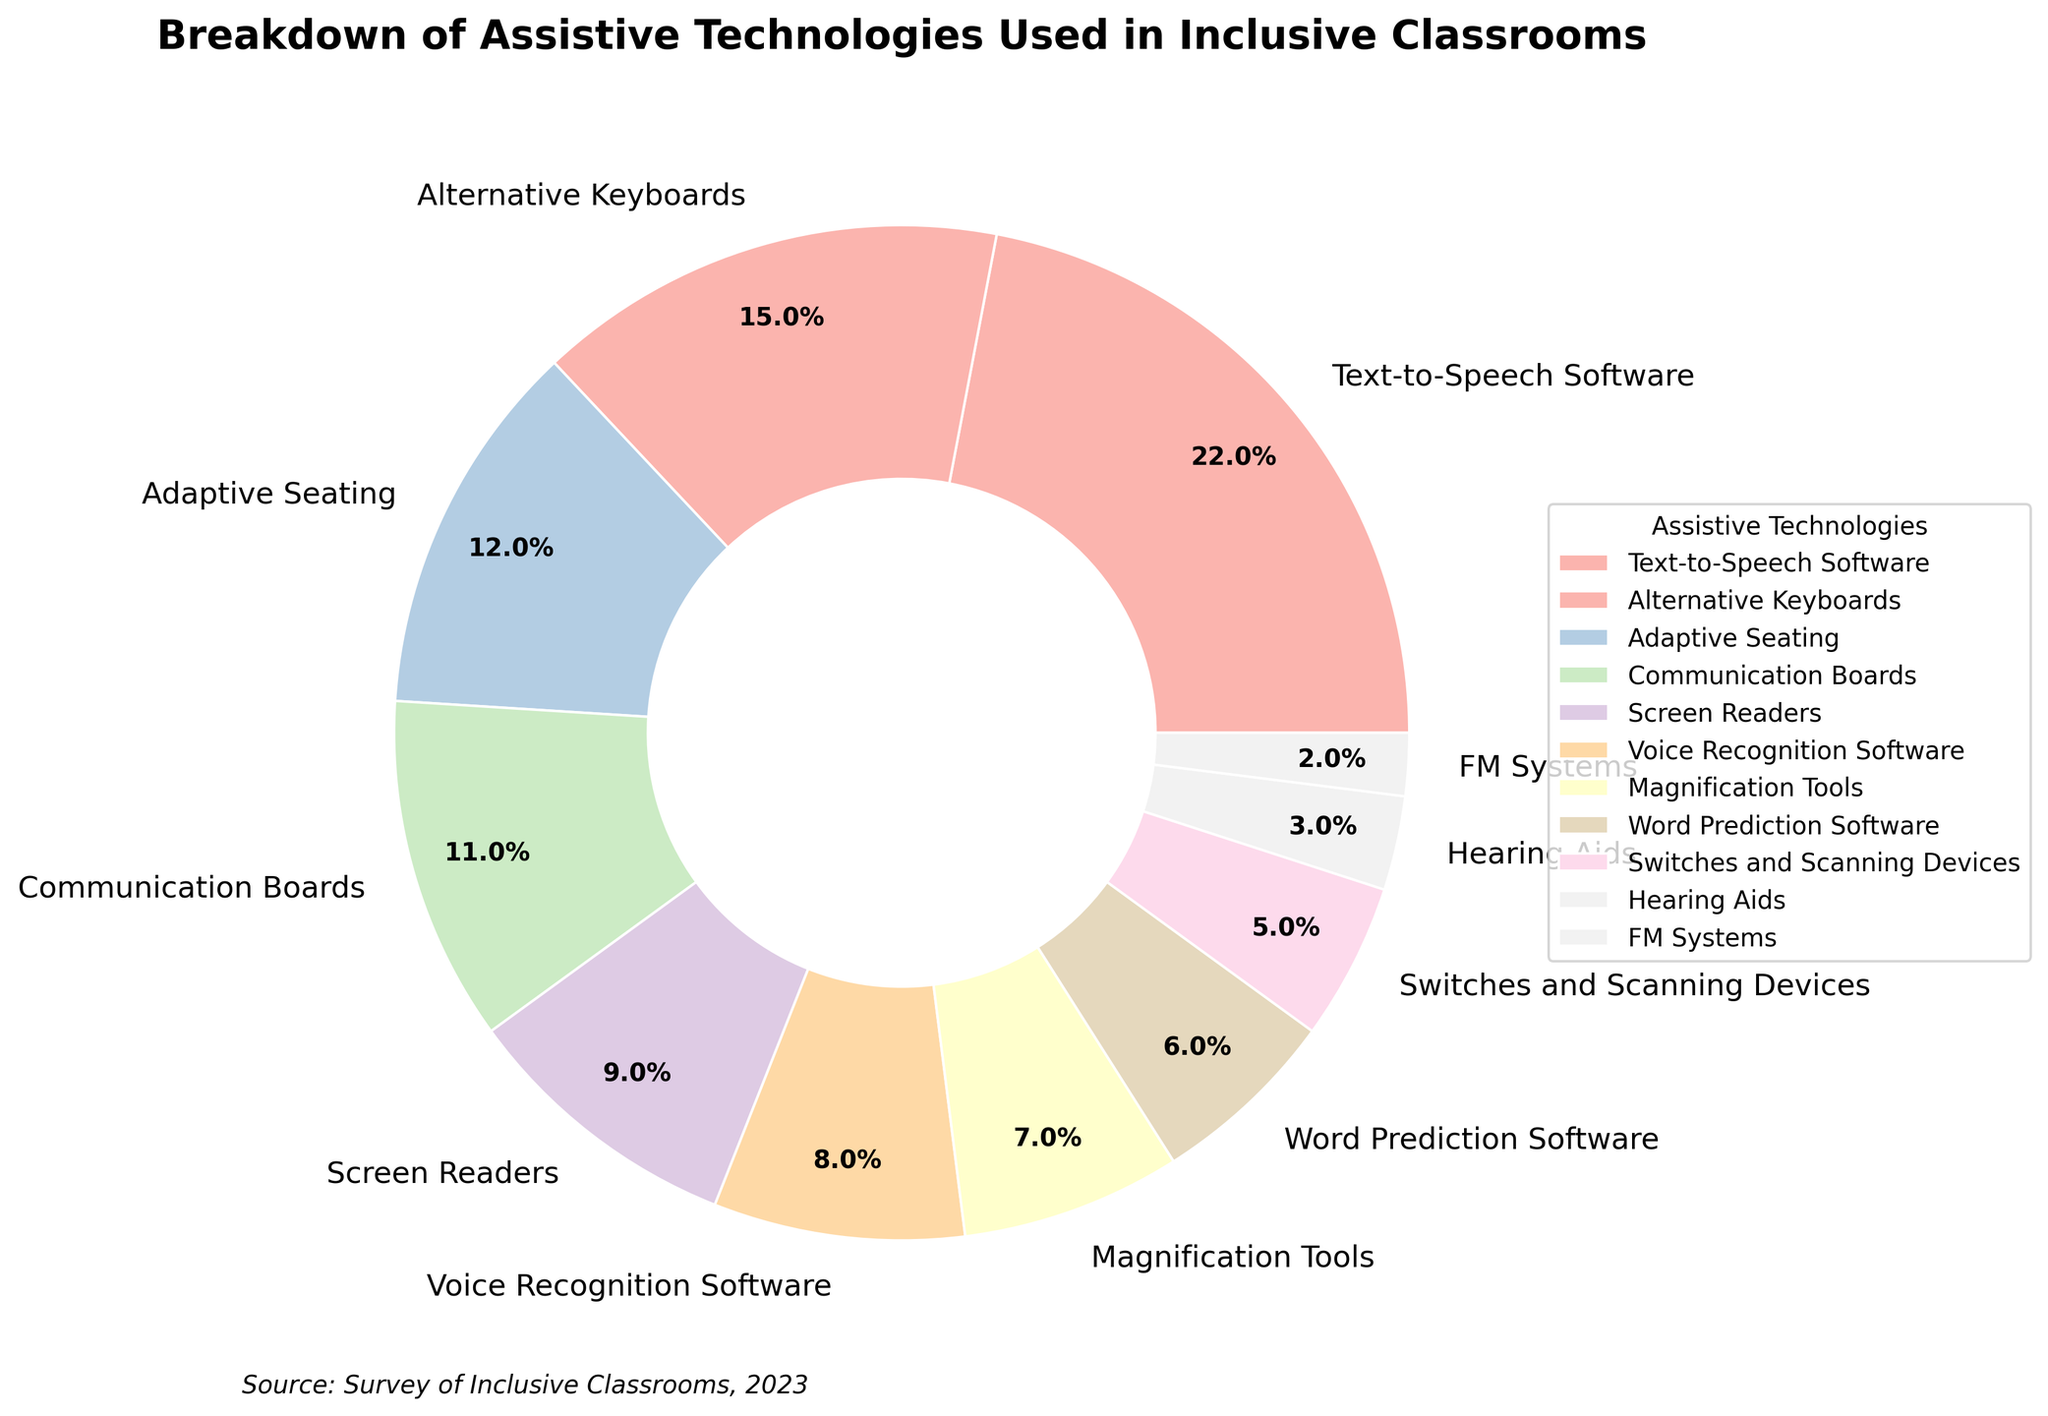What is the most commonly used assistive technology in inclusive classrooms? To determine the most commonly used assistive technology, look for the segment of the pie chart with the largest percentage. The segment labeled "Text-to-Speech Software" has 22%, which is the highest.
Answer: Text-to-Speech Software Which assistive technology has the smallest usage percentage? Locate the segment with the smallest percentage value in the pie chart. The smallest segment is labeled "FM Systems" with 2%.
Answer: FM Systems What is the combined percentage of Alternative Keyboards and Communication Boards? Find the percentage values for Alternative Keyboards and Communication Boards. Add the two values: 15% (Alternative Keyboards) + 11% (Communication Boards) = 26%.
Answer: 26% Compare the usage of Voice Recognition Software and Hearing Aids. Which one is used more, and by how much? Find the percentages for both Voice Recognition Software and Hearing Aids. Voice Recognition Software is at 8% and Hearing Aids are at 3%. Subtract the smaller percentage from the larger one: 8% - 3% = 5%.
Answer: Voice Recognition Software, by 5% What is the difference in usage percentage between Adaptive Seating and Magnification Tools? Determine the percentages for both Adaptive Seating and Magnification Tools. Adaptive Seating is at 12% and Magnification Tools are at 7%. Subtract to find the difference: 12% - 7% = 5%.
Answer: 5% Which assistive technologies together make up less than 10% of the total usage? Observe the pie chart for segments that are each less than 10%. These are Screen Readers (9%), Voice Recognition Software (8%), Magnification Tools (7%), Word Prediction Software (6%), Switches and Scanning Devices (5%), Hearing Aids (3%), and FM Systems (2%).
Answer: Screen Readers, Voice Recognition Software, Magnification Tools, Word Prediction Software, Switches and Scanning Devices, Hearing Aids, FM Systems If you combine the percentages of Adaptive Seating, Communication Boards, and Word Prediction Software, what is the total? Add the percentage values for Adaptive Seating, Communication Boards, and Word Prediction Software. Sum: 12% (Adaptive Seating) + 11% (Communication Boards) + 6% (Word Prediction Software) = 29%.
Answer: 29% What percentage of assistive technologies used fall under the category of screen-related tools (Text-to-Speech Software and Screen Readers)? Identify screen-related tools and sum their percentages. Text-to-Speech Software is 22% and Screen Readers are 9%. Sum: 22% + 9% = 31%.
Answer: 31% Which has a higher usage percentage: Word Prediction Software or Switches and Scanning Devices? Compare the percentage values for Word Prediction Software (6%) and Switches and Scanning Devices (5%). Word Prediction Software has a higher percentage.
Answer: Word Prediction Software How much more frequently are Adaptive Seating tools used compared to FM Systems? Determine the percentages for Adaptive Seating and FM Systems. Adaptive Seating is 12%, and FM Systems are 2%. Subtract to find the difference: 12% - 2% = 10%.
Answer: 10% 